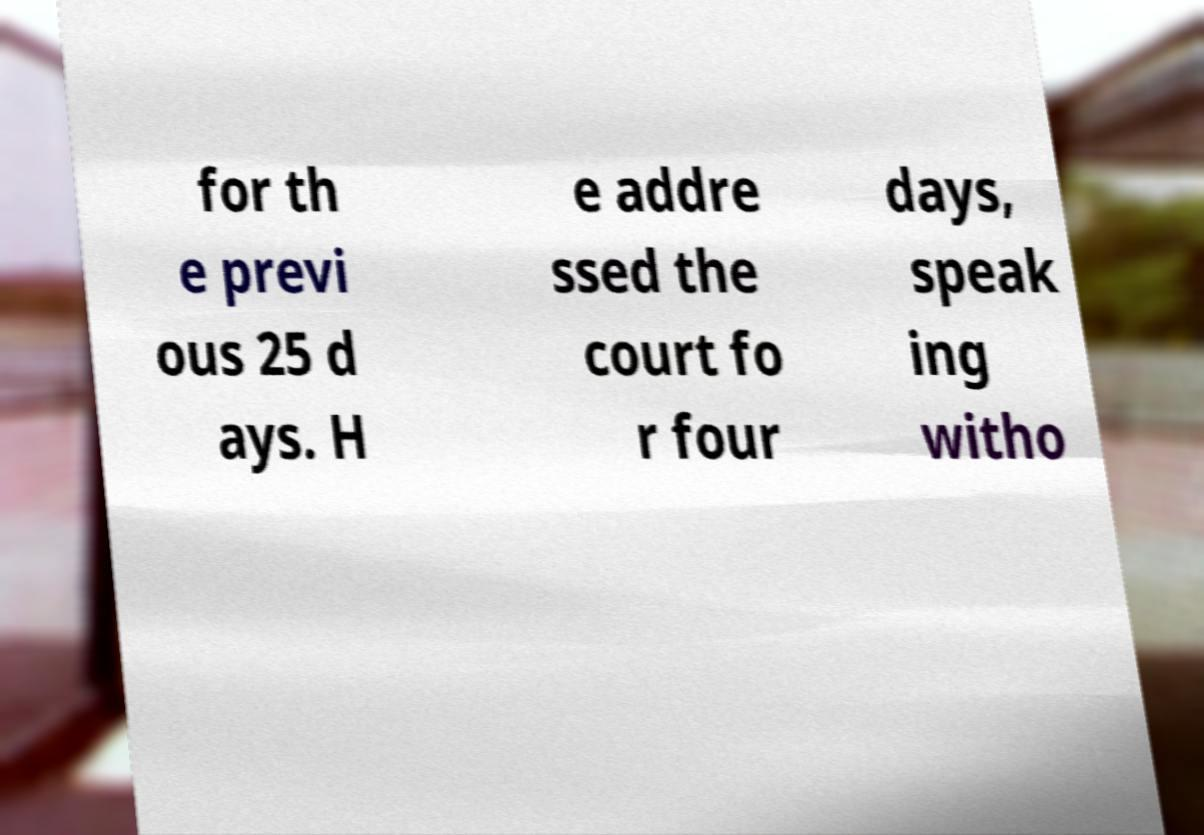Can you accurately transcribe the text from the provided image for me? for th e previ ous 25 d ays. H e addre ssed the court fo r four days, speak ing witho 